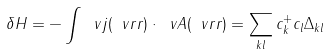<formula> <loc_0><loc_0><loc_500><loc_500>\delta H = - \int \ v j ( \ v r r ) \cdot \ v A ( \ v r r ) = \sum _ { k l } c _ { k } ^ { + } c _ { l } \Delta _ { k l }</formula> 